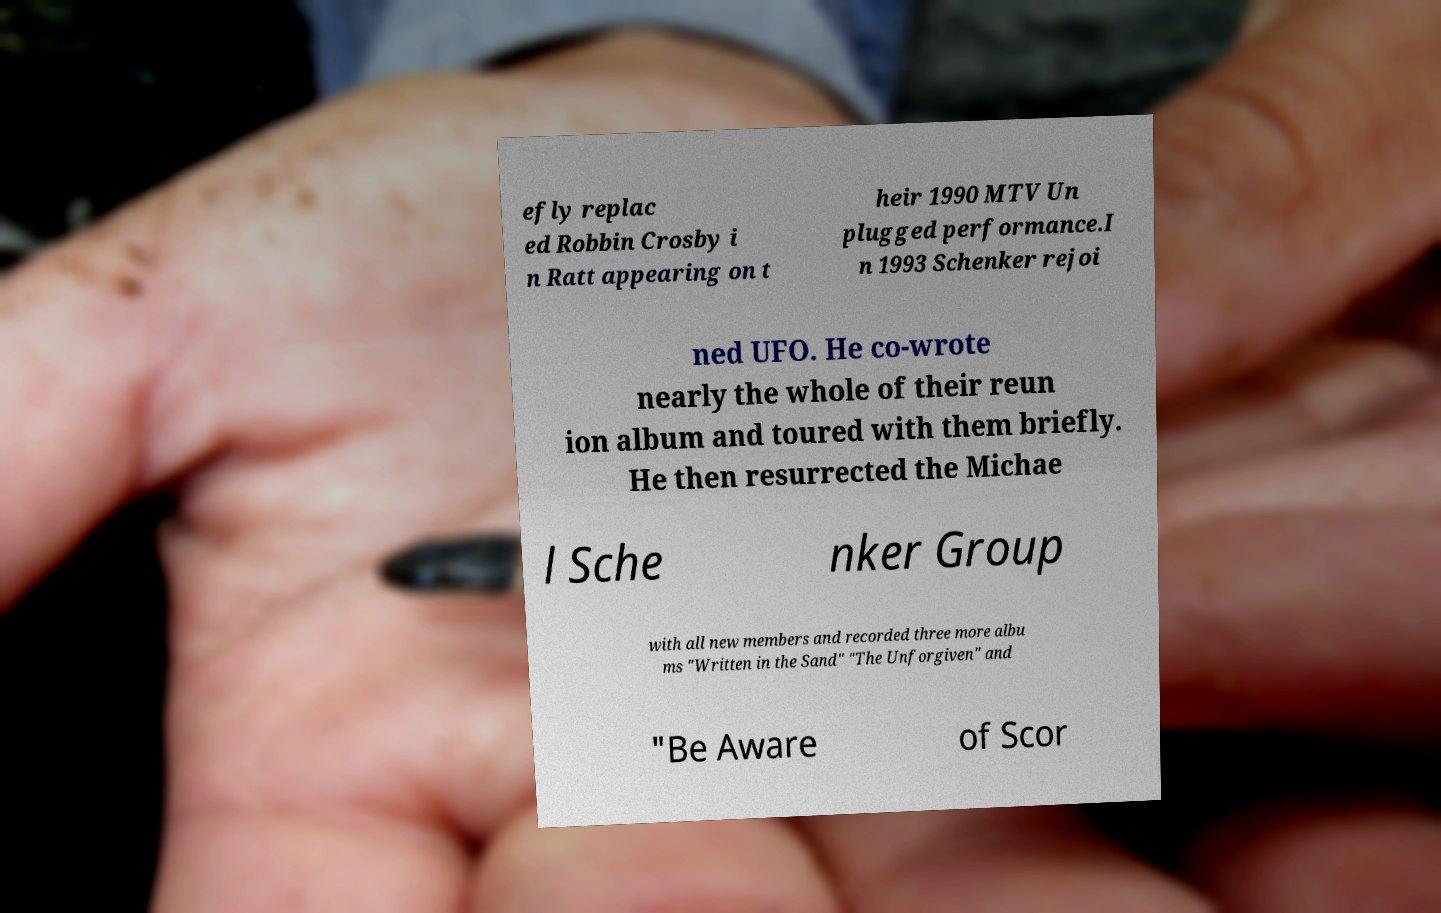Could you extract and type out the text from this image? efly replac ed Robbin Crosby i n Ratt appearing on t heir 1990 MTV Un plugged performance.I n 1993 Schenker rejoi ned UFO. He co-wrote nearly the whole of their reun ion album and toured with them briefly. He then resurrected the Michae l Sche nker Group with all new members and recorded three more albu ms "Written in the Sand" "The Unforgiven" and "Be Aware of Scor 